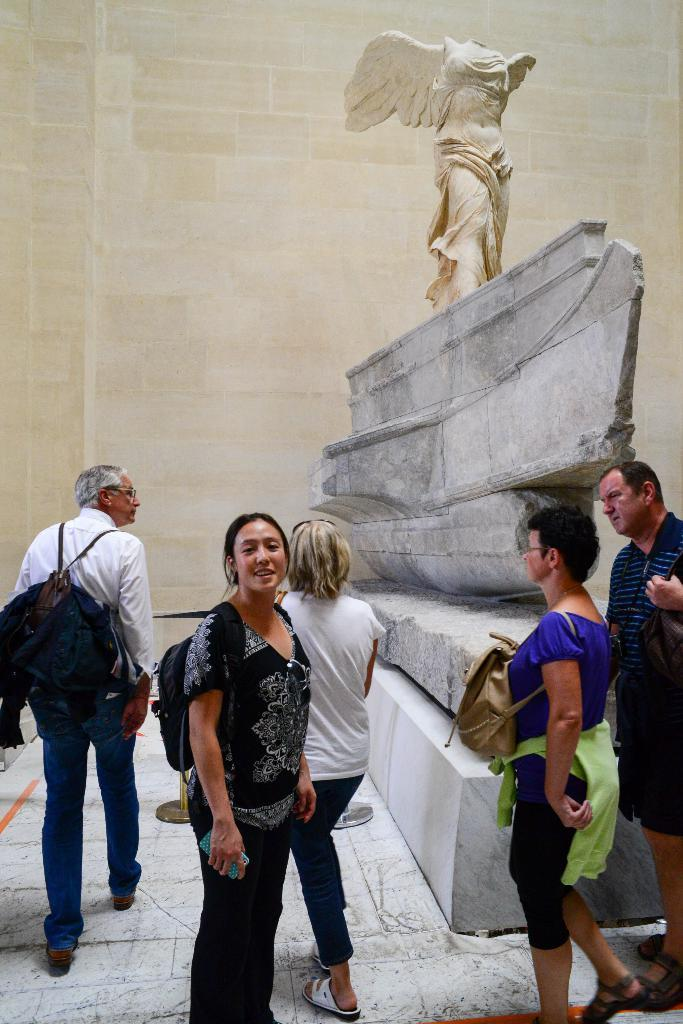What are the people in the image doing? There are people walking and standing in the image. Can you describe any accessories the people are wearing? Some people are wearing bags in the image. What can be seen in the background of the image? There is a statue and a wall in the background of the image. What type of noise is being made by the cast in the image? There is no cast present in the image, and therefore no noise can be attributed to them. 